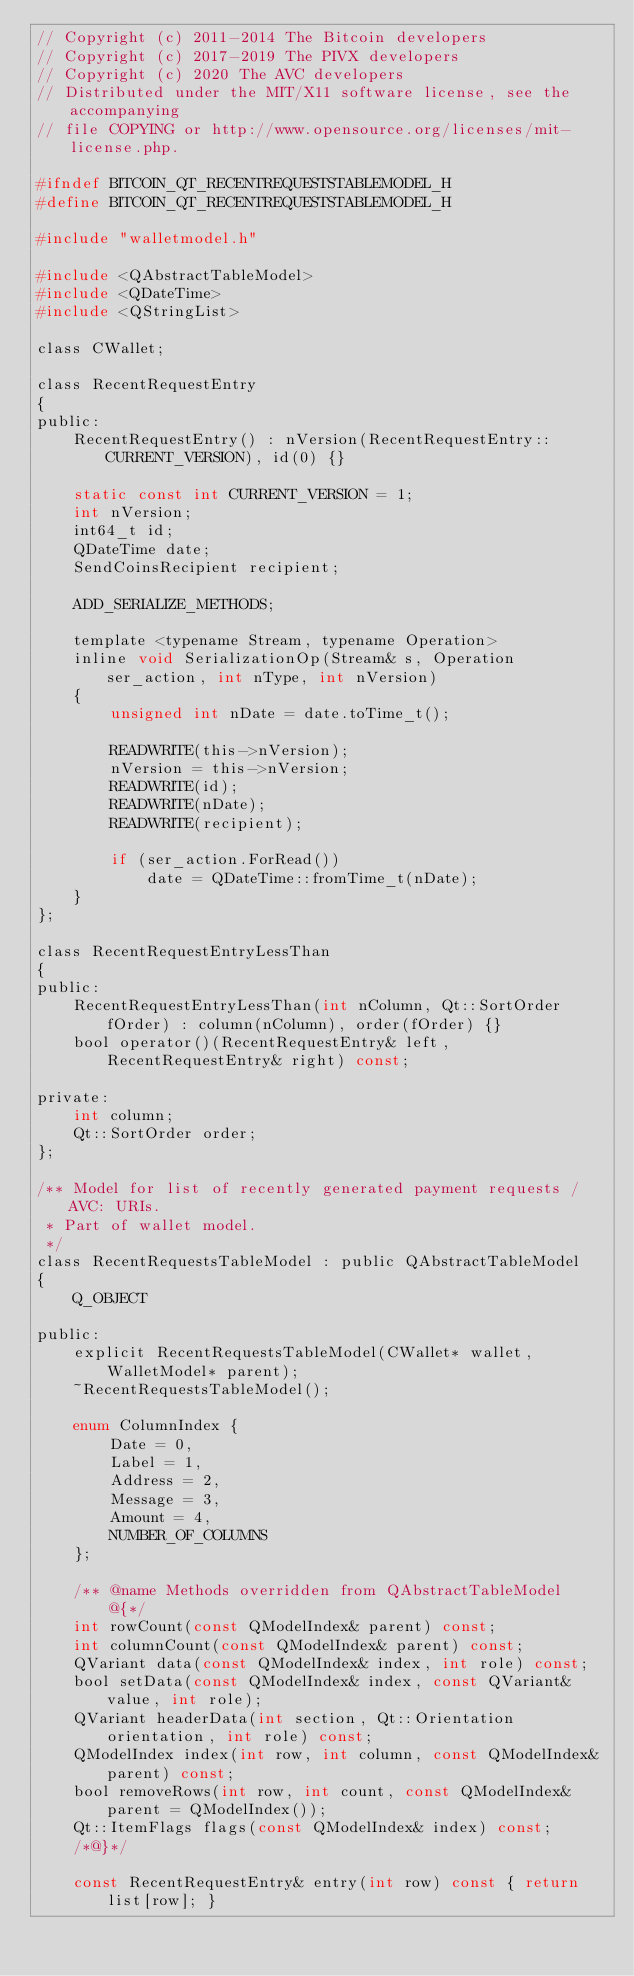Convert code to text. <code><loc_0><loc_0><loc_500><loc_500><_C_>// Copyright (c) 2011-2014 The Bitcoin developers
// Copyright (c) 2017-2019 The PIVX developers
// Copyright (c) 2020 The AVC developers
// Distributed under the MIT/X11 software license, see the accompanying
// file COPYING or http://www.opensource.org/licenses/mit-license.php.

#ifndef BITCOIN_QT_RECENTREQUESTSTABLEMODEL_H
#define BITCOIN_QT_RECENTREQUESTSTABLEMODEL_H

#include "walletmodel.h"

#include <QAbstractTableModel>
#include <QDateTime>
#include <QStringList>

class CWallet;

class RecentRequestEntry
{
public:
    RecentRequestEntry() : nVersion(RecentRequestEntry::CURRENT_VERSION), id(0) {}

    static const int CURRENT_VERSION = 1;
    int nVersion;
    int64_t id;
    QDateTime date;
    SendCoinsRecipient recipient;

    ADD_SERIALIZE_METHODS;

    template <typename Stream, typename Operation>
    inline void SerializationOp(Stream& s, Operation ser_action, int nType, int nVersion)
    {
        unsigned int nDate = date.toTime_t();

        READWRITE(this->nVersion);
        nVersion = this->nVersion;
        READWRITE(id);
        READWRITE(nDate);
        READWRITE(recipient);

        if (ser_action.ForRead())
            date = QDateTime::fromTime_t(nDate);
    }
};

class RecentRequestEntryLessThan
{
public:
    RecentRequestEntryLessThan(int nColumn, Qt::SortOrder fOrder) : column(nColumn), order(fOrder) {}
    bool operator()(RecentRequestEntry& left, RecentRequestEntry& right) const;

private:
    int column;
    Qt::SortOrder order;
};

/** Model for list of recently generated payment requests / AVC: URIs.
 * Part of wallet model.
 */
class RecentRequestsTableModel : public QAbstractTableModel
{
    Q_OBJECT

public:
    explicit RecentRequestsTableModel(CWallet* wallet, WalletModel* parent);
    ~RecentRequestsTableModel();

    enum ColumnIndex {
        Date = 0,
        Label = 1,
        Address = 2,
        Message = 3,
        Amount = 4,
        NUMBER_OF_COLUMNS
    };

    /** @name Methods overridden from QAbstractTableModel
        @{*/
    int rowCount(const QModelIndex& parent) const;
    int columnCount(const QModelIndex& parent) const;
    QVariant data(const QModelIndex& index, int role) const;
    bool setData(const QModelIndex& index, const QVariant& value, int role);
    QVariant headerData(int section, Qt::Orientation orientation, int role) const;
    QModelIndex index(int row, int column, const QModelIndex& parent) const;
    bool removeRows(int row, int count, const QModelIndex& parent = QModelIndex());
    Qt::ItemFlags flags(const QModelIndex& index) const;
    /*@}*/

    const RecentRequestEntry& entry(int row) const { return list[row]; }</code> 